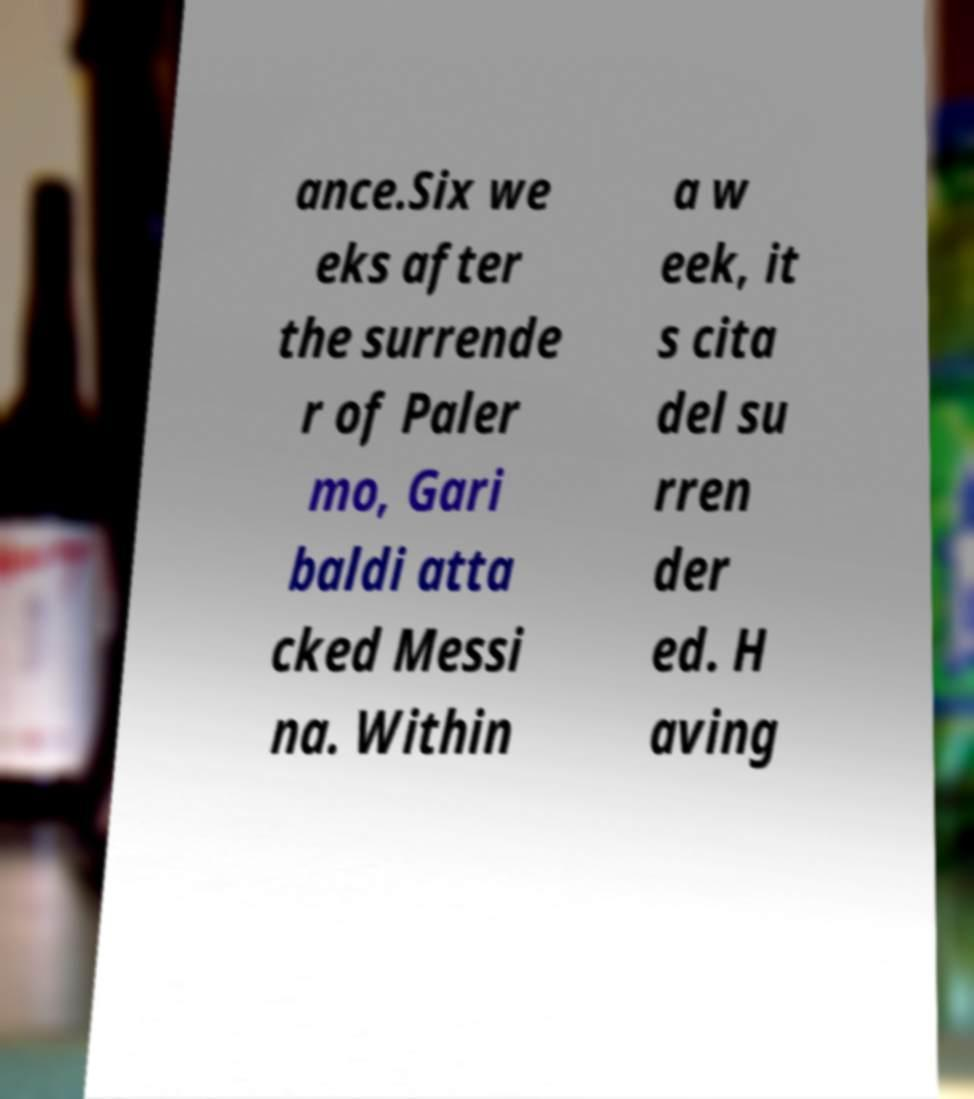There's text embedded in this image that I need extracted. Can you transcribe it verbatim? ance.Six we eks after the surrende r of Paler mo, Gari baldi atta cked Messi na. Within a w eek, it s cita del su rren der ed. H aving 